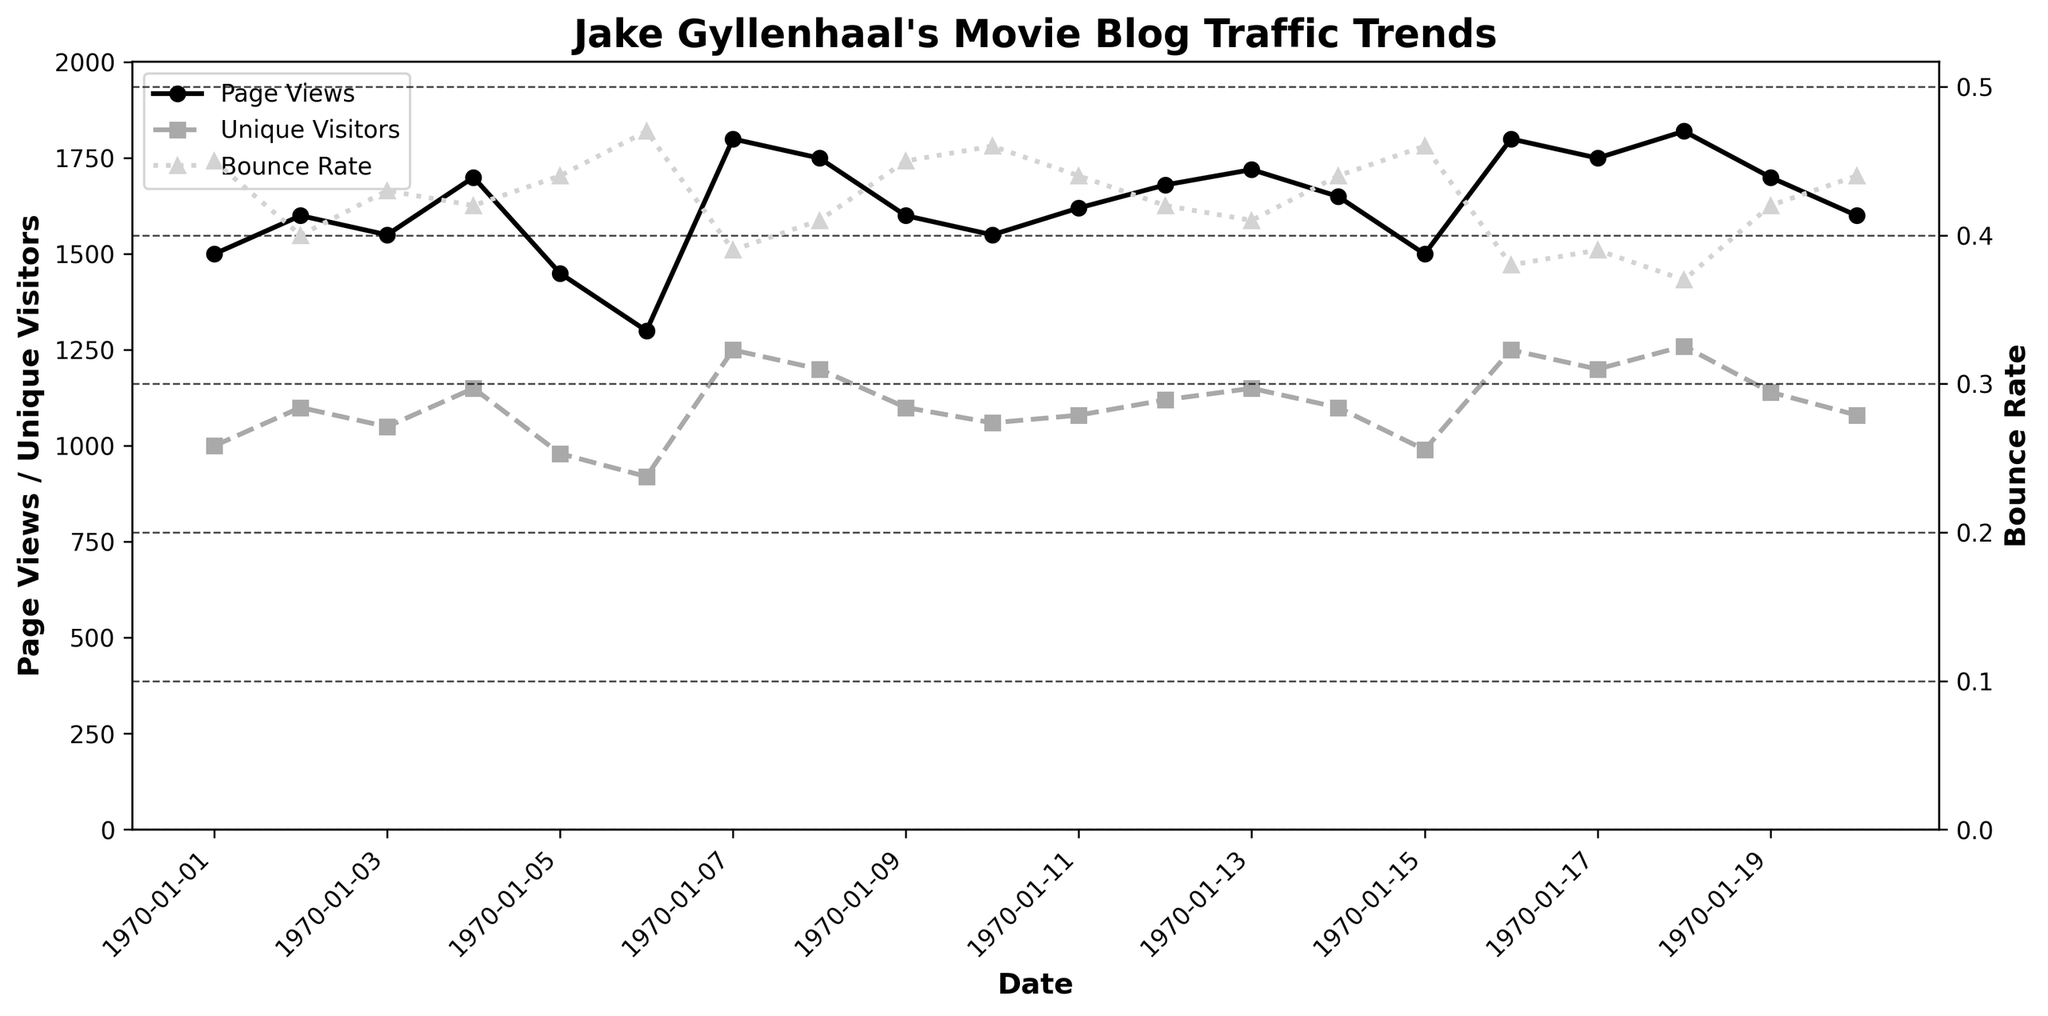How many data points are plotted for Page Views? Count the number of data points plotted on the Page Views line. There is one data point for each date from January 1 to January 20, 2023. There are 20 dates, so there are 20 data points.
Answer: 20 Which date has the highest number of unique visitors? Observe the Unique Visitors line (dark gray, dashed line) and identify the peak value. The highest unique visitors occur on January 18, 2023, with 1260 visitors.
Answer: January 18, 2023 What is the bounce rate on January 07, 2023? Locate the date January 07, 2023, on the x-axis, and identify the Bounce Rate (light gray, dotted line). The bounce rate is 0.39.
Answer: 0.39 Is the bounce rate on January 03, 2023, higher or lower than on January 08, 2023? Compare the Bounce Rate (light gray, dotted line) values for January 03 (0.43) and January 08 (0.41). The bounce rate on January 03 is higher.
Answer: Higher What's the average number of page views between January 01 and January 10, 2023? Sum the Page Views values from January 01 to January 10 and then divide by the number of days. (1500+1600+1550+1700+1450+1300+1800+1750+1600+1550)/10 = 15800/10 = 1580
Answer: 1580 How does the trend of Page Views compare with Unique Visitors during the period from January 15 to January 20, 2023? Observe the trends of both lines (Page Views in black and Unique Visitors in dark gray). From January 15 to January 20, both have a similar upward trend, peaking around January 18, 2023.
Answer: Similar upward trend What is the decrease in Page Views from January 04 to January 06, 2023? Subtract the Page Views on January 06 from those on January 04: 1700 (Jan 04) - 1300 (Jan 06) = 400.
Answer: 400 On which date did the bounce rate first drop below 0.40? Look at the Bounce Rate line (light gray) and find the first date when the value drops below 0.40. This happens on January 07, 2023, with a bounce rate of 0.39.
Answer: January 07, 2023 What is the Page Views to Unique Visitors ratio on January 12, 2023? Divide the Page Views by Unique Visitors on January 12: 1680 / 1120 = 1.5
Answer: 1.5 Does the average session duration increase or decrease on days with higher unique visitor counts? Observe the relationship between peaks in Unique Visitors (dark gray line) and corresponding Average Session Duration. Notice that higher unique visitor counts (like on January 16-18) correspond to higher average session durations around 4.0.
Answer: Increase 